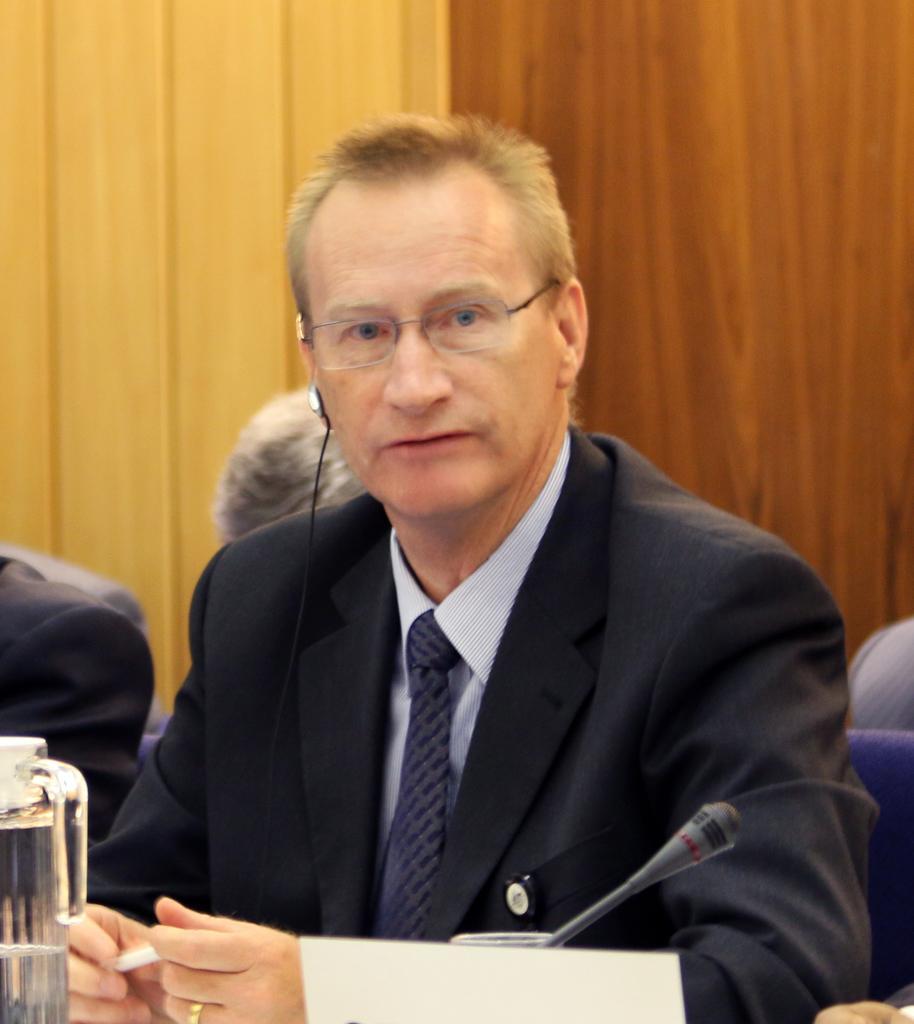Describe this image in one or two sentences. In front of the picture, we see a man in the black blazer is sitting on the chair. He is wearing the spectacles. In front of him, we see a glass jar, name board and a microphone. Behind him, we see the people are sitting on the chairs. In the background, we see a wooden wall in brown color. On the left side, we see a wall in yellow color. 